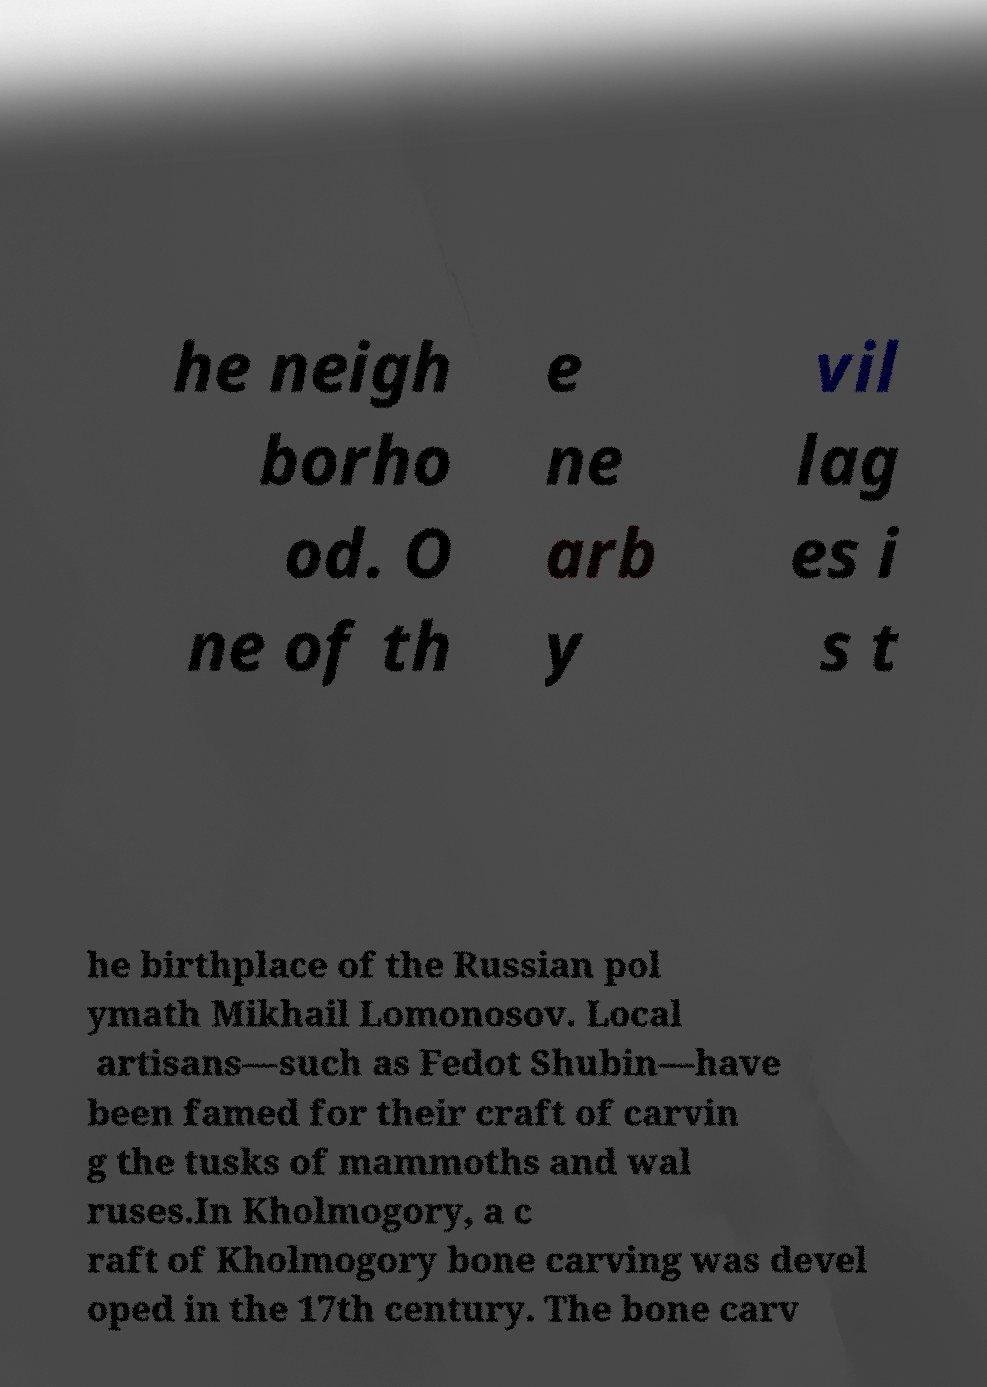For documentation purposes, I need the text within this image transcribed. Could you provide that? he neigh borho od. O ne of th e ne arb y vil lag es i s t he birthplace of the Russian pol ymath Mikhail Lomonosov. Local artisans—such as Fedot Shubin—have been famed for their craft of carvin g the tusks of mammoths and wal ruses.In Kholmogory, a c raft of Kholmogory bone carving was devel oped in the 17th century. The bone carv 